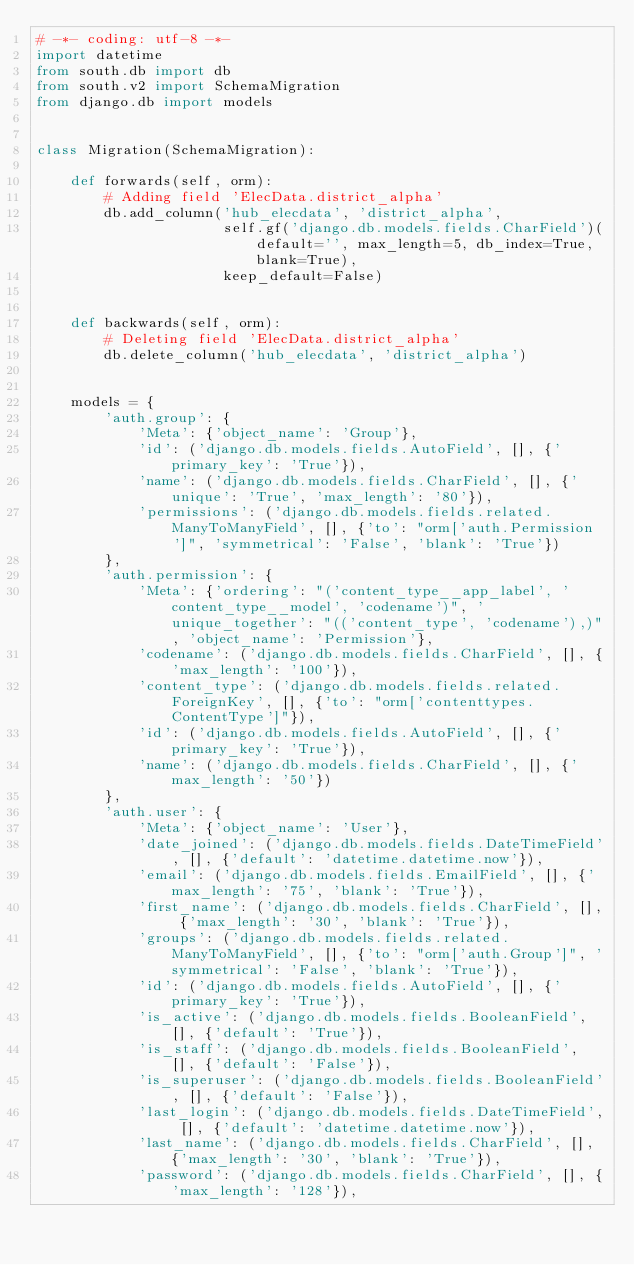Convert code to text. <code><loc_0><loc_0><loc_500><loc_500><_Python_># -*- coding: utf-8 -*-
import datetime
from south.db import db
from south.v2 import SchemaMigration
from django.db import models


class Migration(SchemaMigration):

    def forwards(self, orm):
        # Adding field 'ElecData.district_alpha'
        db.add_column('hub_elecdata', 'district_alpha',
                      self.gf('django.db.models.fields.CharField')(default='', max_length=5, db_index=True, blank=True),
                      keep_default=False)


    def backwards(self, orm):
        # Deleting field 'ElecData.district_alpha'
        db.delete_column('hub_elecdata', 'district_alpha')


    models = {
        'auth.group': {
            'Meta': {'object_name': 'Group'},
            'id': ('django.db.models.fields.AutoField', [], {'primary_key': 'True'}),
            'name': ('django.db.models.fields.CharField', [], {'unique': 'True', 'max_length': '80'}),
            'permissions': ('django.db.models.fields.related.ManyToManyField', [], {'to': "orm['auth.Permission']", 'symmetrical': 'False', 'blank': 'True'})
        },
        'auth.permission': {
            'Meta': {'ordering': "('content_type__app_label', 'content_type__model', 'codename')", 'unique_together': "(('content_type', 'codename'),)", 'object_name': 'Permission'},
            'codename': ('django.db.models.fields.CharField', [], {'max_length': '100'}),
            'content_type': ('django.db.models.fields.related.ForeignKey', [], {'to': "orm['contenttypes.ContentType']"}),
            'id': ('django.db.models.fields.AutoField', [], {'primary_key': 'True'}),
            'name': ('django.db.models.fields.CharField', [], {'max_length': '50'})
        },
        'auth.user': {
            'Meta': {'object_name': 'User'},
            'date_joined': ('django.db.models.fields.DateTimeField', [], {'default': 'datetime.datetime.now'}),
            'email': ('django.db.models.fields.EmailField', [], {'max_length': '75', 'blank': 'True'}),
            'first_name': ('django.db.models.fields.CharField', [], {'max_length': '30', 'blank': 'True'}),
            'groups': ('django.db.models.fields.related.ManyToManyField', [], {'to': "orm['auth.Group']", 'symmetrical': 'False', 'blank': 'True'}),
            'id': ('django.db.models.fields.AutoField', [], {'primary_key': 'True'}),
            'is_active': ('django.db.models.fields.BooleanField', [], {'default': 'True'}),
            'is_staff': ('django.db.models.fields.BooleanField', [], {'default': 'False'}),
            'is_superuser': ('django.db.models.fields.BooleanField', [], {'default': 'False'}),
            'last_login': ('django.db.models.fields.DateTimeField', [], {'default': 'datetime.datetime.now'}),
            'last_name': ('django.db.models.fields.CharField', [], {'max_length': '30', 'blank': 'True'}),
            'password': ('django.db.models.fields.CharField', [], {'max_length': '128'}),</code> 